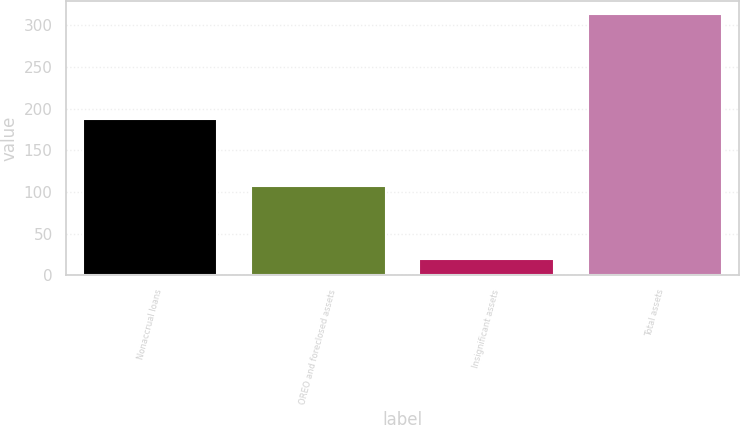Convert chart to OTSL. <chart><loc_0><loc_0><loc_500><loc_500><bar_chart><fcel>Nonaccrual loans<fcel>OREO and foreclosed assets<fcel>Insignificant assets<fcel>Total assets<nl><fcel>187<fcel>107<fcel>19<fcel>313<nl></chart> 